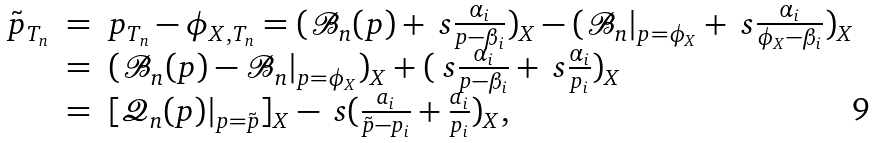<formula> <loc_0><loc_0><loc_500><loc_500>\begin{array} { l l l } \tilde { p } _ { T _ { n } } & = & p _ { T _ { n } } - \phi _ { X , T _ { n } } = ( { \mathcal { B } } _ { n } ( p ) + \ s \frac { \alpha _ { i } } { p - \beta _ { i } } ) _ { X } - ( { \mathcal { B } } _ { n } | _ { p = \phi _ { X } } + \ s \frac { \alpha _ { i } } { \phi _ { X } - \beta _ { i } } ) _ { X } \\ & = & ( { \mathcal { B } } _ { n } ( p ) - { \mathcal { B } } _ { n } | _ { p = \phi _ { X } } ) _ { X } + ( \ s \frac { \alpha _ { i } } { p - \beta _ { i } } + \ s \frac { \alpha _ { i } } { p _ { i } } ) _ { X } \\ & = & [ { \mathcal { Q } } _ { n } ( p ) | _ { p = \tilde { p } } ] _ { X } - \ s ( \frac { a _ { i } } { \tilde { p } - p _ { i } } + \frac { a _ { i } } { p _ { i } } ) _ { X } , \end{array}</formula> 